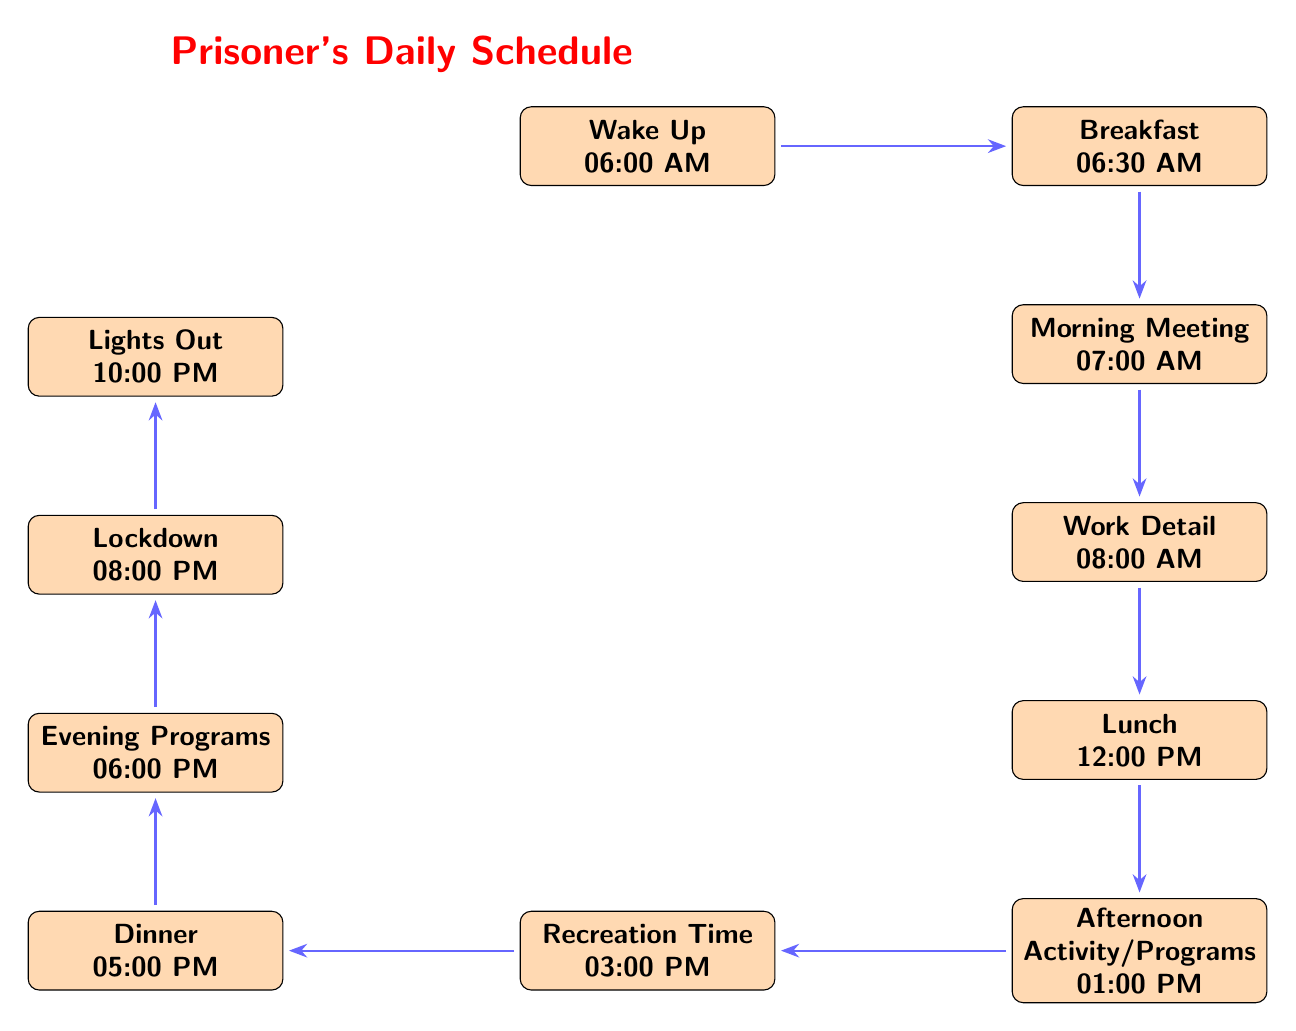What time do prisoners have breakfast? According to the diagram, breakfast is listed directly after "Wake Up" and occurs at 6:30 AM.
Answer: 6:30 AM What is the first activity in the schedule? The diagram shows that the first event after "Wake Up" is "Breakfast," which occurs at 6:30 AM.
Answer: Breakfast How many total activities are in the daily schedule? By counting each event listed in the diagram, there are 10 distinct activities: Wake Up, Breakfast, Morning Meeting, Work Detail, Lunch, Afternoon Activity, Recreation Time, Dinner, Evening Programs, Lockdown, and Lights Out.
Answer: 10 What activity follows Lunch in the schedule? The diagram indicates that after "Lunch," the next activity is "Afternoon Activity/Programs," starting at 1:00 PM.
Answer: Afternoon Activity/Programs At what time does Lockdown start? The diagram clearly labels that "Lockdown" occurs at 8:00 PM, directly following the "Evening Programs."
Answer: 8:00 PM Which two activities are scheduled between Lunch and Dinner? To identify the two activities, we look at the events listed after "Lunch" in the diagram, which are "Afternoon Activity/Programs" at 1:00 PM and "Recreation Time" at 3:00 PM.
Answer: Afternoon Activity/Programs and Recreation Time What is the last activity of the day? The diagram shows that "Lights Out" is the final event of the day, which occurs at 10:00 PM.
Answer: Lights Out What time does the Morning Meeting occur? In the diagram, the "Morning Meeting" is positioned just below "Breakfast," indicating it starts at 7:00 AM.
Answer: 7:00 AM What time is the last meal of the day? The diagram specifies that "Dinner" is the final meal and it is scheduled for 5:00 PM.
Answer: 5:00 PM 